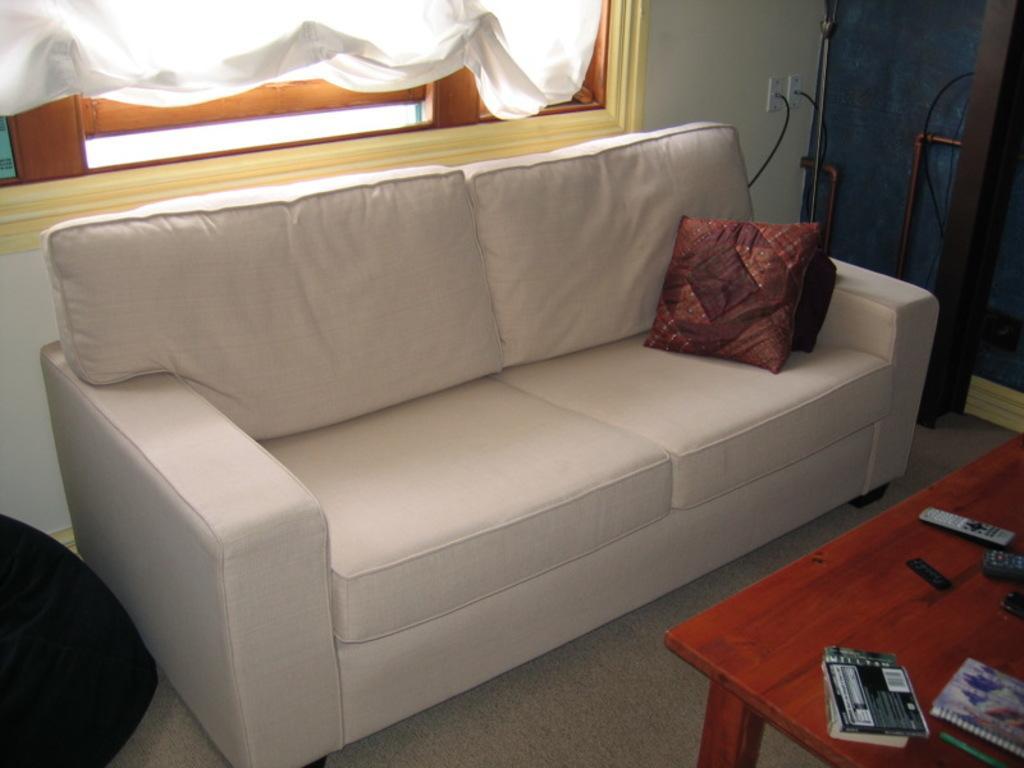Could you give a brief overview of what you see in this image? As we can see in the image there is a window, sofa, pillows and a table. On table there are books, pen and remote. 